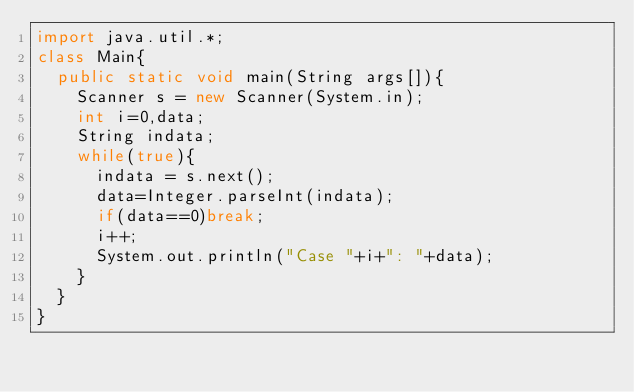Convert code to text. <code><loc_0><loc_0><loc_500><loc_500><_Java_>import java.util.*;
class Main{
	public static void main(String args[]){
		Scanner s = new Scanner(System.in);
		int i=0,data;
		String indata;
		while(true){
			indata = s.next();
			data=Integer.parseInt(indata);
			if(data==0)break;
			i++;
			System.out.println("Case "+i+": "+data);
		}
	}
}</code> 